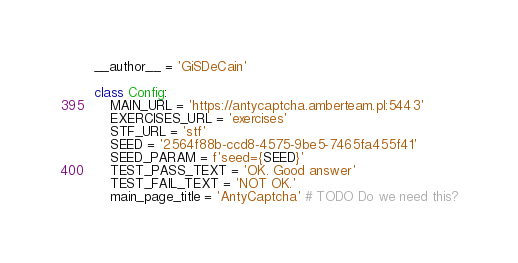Convert code to text. <code><loc_0><loc_0><loc_500><loc_500><_Python_>__author__ = 'GiSDeCain'

class Config:
    MAIN_URL = 'https://antycaptcha.amberteam.pl:5443'
    EXERCISES_URL = 'exercises'
    STF_URL = 'stf'
    SEED = '2564f88b-ccd8-4575-9be5-7465fa455f41'
    SEED_PARAM = f'seed={SEED}'
    TEST_PASS_TEXT = 'OK. Good answer'
    TEST_FAIL_TEXT = 'NOT OK.'
    main_page_title = 'AntyCaptcha' # TODO Do we need this?

</code> 